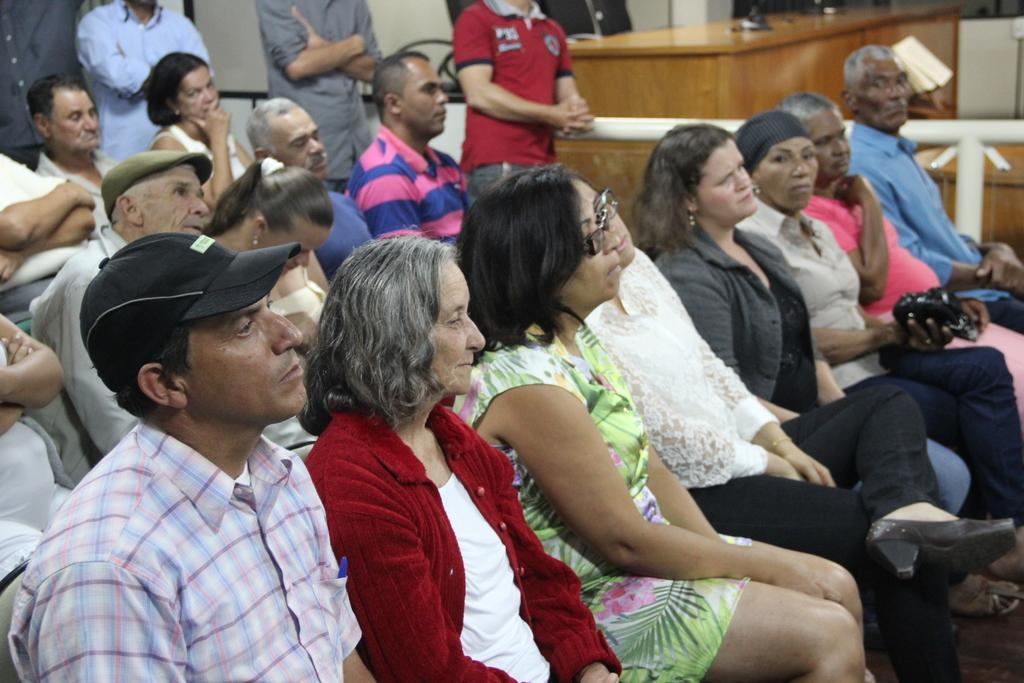What are the people in the image doing? The people in the image are sitting. How many people are standing in the background of the image? There are four persons standing in the background of the image. What can be used for sitting in the image? There are empty chairs in the image. What type of table is present in the image? There is a wooden table in the image. What type of drain can be seen in the image? There is no drain present in the image. How many stars are visible in the image? There are no stars visible in the image. 